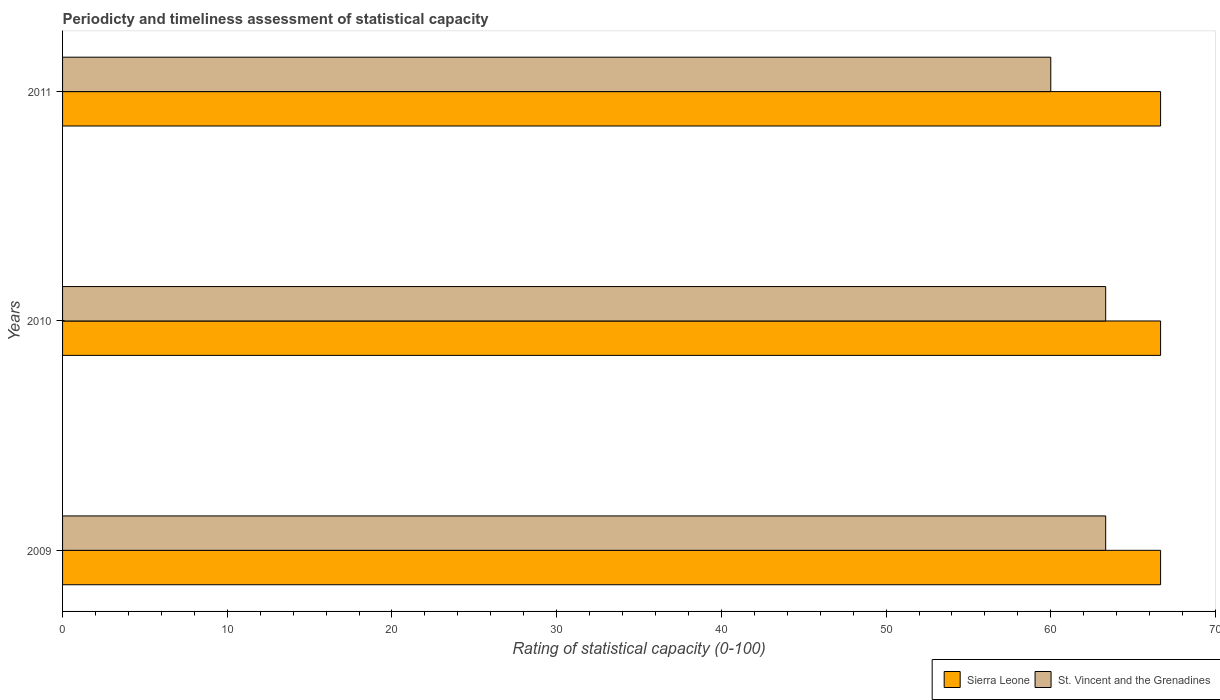How many different coloured bars are there?
Keep it short and to the point. 2. How many bars are there on the 3rd tick from the bottom?
Provide a short and direct response. 2. What is the label of the 3rd group of bars from the top?
Provide a succinct answer. 2009. In how many cases, is the number of bars for a given year not equal to the number of legend labels?
Keep it short and to the point. 0. What is the rating of statistical capacity in Sierra Leone in 2011?
Your response must be concise. 66.67. Across all years, what is the maximum rating of statistical capacity in Sierra Leone?
Provide a succinct answer. 66.67. In which year was the rating of statistical capacity in St. Vincent and the Grenadines maximum?
Give a very brief answer. 2009. What is the total rating of statistical capacity in St. Vincent and the Grenadines in the graph?
Provide a succinct answer. 186.67. What is the difference between the rating of statistical capacity in St. Vincent and the Grenadines in 2010 and the rating of statistical capacity in Sierra Leone in 2009?
Ensure brevity in your answer.  -3.33. What is the average rating of statistical capacity in St. Vincent and the Grenadines per year?
Provide a short and direct response. 62.22. In the year 2009, what is the difference between the rating of statistical capacity in Sierra Leone and rating of statistical capacity in St. Vincent and the Grenadines?
Provide a short and direct response. 3.33. What is the ratio of the rating of statistical capacity in St. Vincent and the Grenadines in 2010 to that in 2011?
Offer a very short reply. 1.06. Is the difference between the rating of statistical capacity in Sierra Leone in 2010 and 2011 greater than the difference between the rating of statistical capacity in St. Vincent and the Grenadines in 2010 and 2011?
Keep it short and to the point. No. In how many years, is the rating of statistical capacity in Sierra Leone greater than the average rating of statistical capacity in Sierra Leone taken over all years?
Provide a short and direct response. 0. Is the sum of the rating of statistical capacity in Sierra Leone in 2009 and 2010 greater than the maximum rating of statistical capacity in St. Vincent and the Grenadines across all years?
Keep it short and to the point. Yes. What does the 2nd bar from the top in 2010 represents?
Make the answer very short. Sierra Leone. What does the 1st bar from the bottom in 2011 represents?
Your answer should be compact. Sierra Leone. How many bars are there?
Provide a short and direct response. 6. What is the difference between two consecutive major ticks on the X-axis?
Offer a terse response. 10. How many legend labels are there?
Keep it short and to the point. 2. How are the legend labels stacked?
Keep it short and to the point. Horizontal. What is the title of the graph?
Provide a short and direct response. Periodicty and timeliness assessment of statistical capacity. What is the label or title of the X-axis?
Your answer should be compact. Rating of statistical capacity (0-100). What is the Rating of statistical capacity (0-100) of Sierra Leone in 2009?
Make the answer very short. 66.67. What is the Rating of statistical capacity (0-100) in St. Vincent and the Grenadines in 2009?
Give a very brief answer. 63.33. What is the Rating of statistical capacity (0-100) of Sierra Leone in 2010?
Provide a succinct answer. 66.67. What is the Rating of statistical capacity (0-100) in St. Vincent and the Grenadines in 2010?
Provide a succinct answer. 63.33. What is the Rating of statistical capacity (0-100) of Sierra Leone in 2011?
Your answer should be compact. 66.67. What is the Rating of statistical capacity (0-100) in St. Vincent and the Grenadines in 2011?
Provide a succinct answer. 60. Across all years, what is the maximum Rating of statistical capacity (0-100) in Sierra Leone?
Provide a short and direct response. 66.67. Across all years, what is the maximum Rating of statistical capacity (0-100) in St. Vincent and the Grenadines?
Offer a very short reply. 63.33. Across all years, what is the minimum Rating of statistical capacity (0-100) of Sierra Leone?
Make the answer very short. 66.67. What is the total Rating of statistical capacity (0-100) in St. Vincent and the Grenadines in the graph?
Give a very brief answer. 186.67. What is the difference between the Rating of statistical capacity (0-100) in Sierra Leone in 2009 and that in 2010?
Your answer should be very brief. 0. What is the difference between the Rating of statistical capacity (0-100) in Sierra Leone in 2009 and that in 2011?
Your answer should be compact. 0. What is the difference between the Rating of statistical capacity (0-100) in Sierra Leone in 2010 and that in 2011?
Offer a terse response. 0. What is the difference between the Rating of statistical capacity (0-100) of Sierra Leone in 2010 and the Rating of statistical capacity (0-100) of St. Vincent and the Grenadines in 2011?
Your response must be concise. 6.67. What is the average Rating of statistical capacity (0-100) in Sierra Leone per year?
Your answer should be very brief. 66.67. What is the average Rating of statistical capacity (0-100) of St. Vincent and the Grenadines per year?
Keep it short and to the point. 62.22. In the year 2011, what is the difference between the Rating of statistical capacity (0-100) of Sierra Leone and Rating of statistical capacity (0-100) of St. Vincent and the Grenadines?
Offer a very short reply. 6.67. What is the ratio of the Rating of statistical capacity (0-100) in St. Vincent and the Grenadines in 2009 to that in 2010?
Provide a succinct answer. 1. What is the ratio of the Rating of statistical capacity (0-100) of Sierra Leone in 2009 to that in 2011?
Give a very brief answer. 1. What is the ratio of the Rating of statistical capacity (0-100) of St. Vincent and the Grenadines in 2009 to that in 2011?
Provide a succinct answer. 1.06. What is the ratio of the Rating of statistical capacity (0-100) of St. Vincent and the Grenadines in 2010 to that in 2011?
Provide a short and direct response. 1.06. What is the difference between the highest and the second highest Rating of statistical capacity (0-100) in St. Vincent and the Grenadines?
Your answer should be compact. 0. What is the difference between the highest and the lowest Rating of statistical capacity (0-100) in St. Vincent and the Grenadines?
Give a very brief answer. 3.33. 